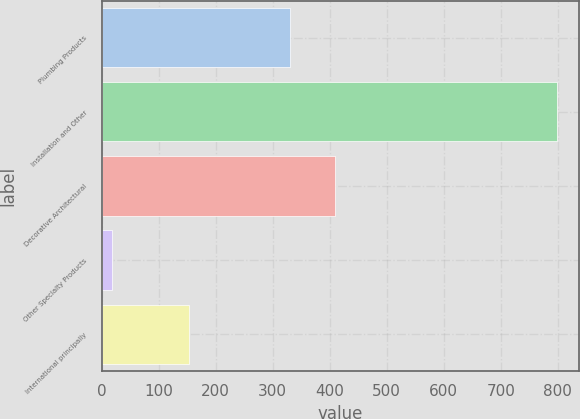<chart> <loc_0><loc_0><loc_500><loc_500><bar_chart><fcel>Plumbing Products<fcel>Installation and Other<fcel>Decorative Architectural<fcel>Other Specialty Products<fcel>International principally<nl><fcel>331<fcel>798<fcel>408.9<fcel>19<fcel>154<nl></chart> 